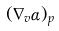Convert formula to latex. <formula><loc_0><loc_0><loc_500><loc_500>( \nabla _ { v } \alpha ) _ { p }</formula> 